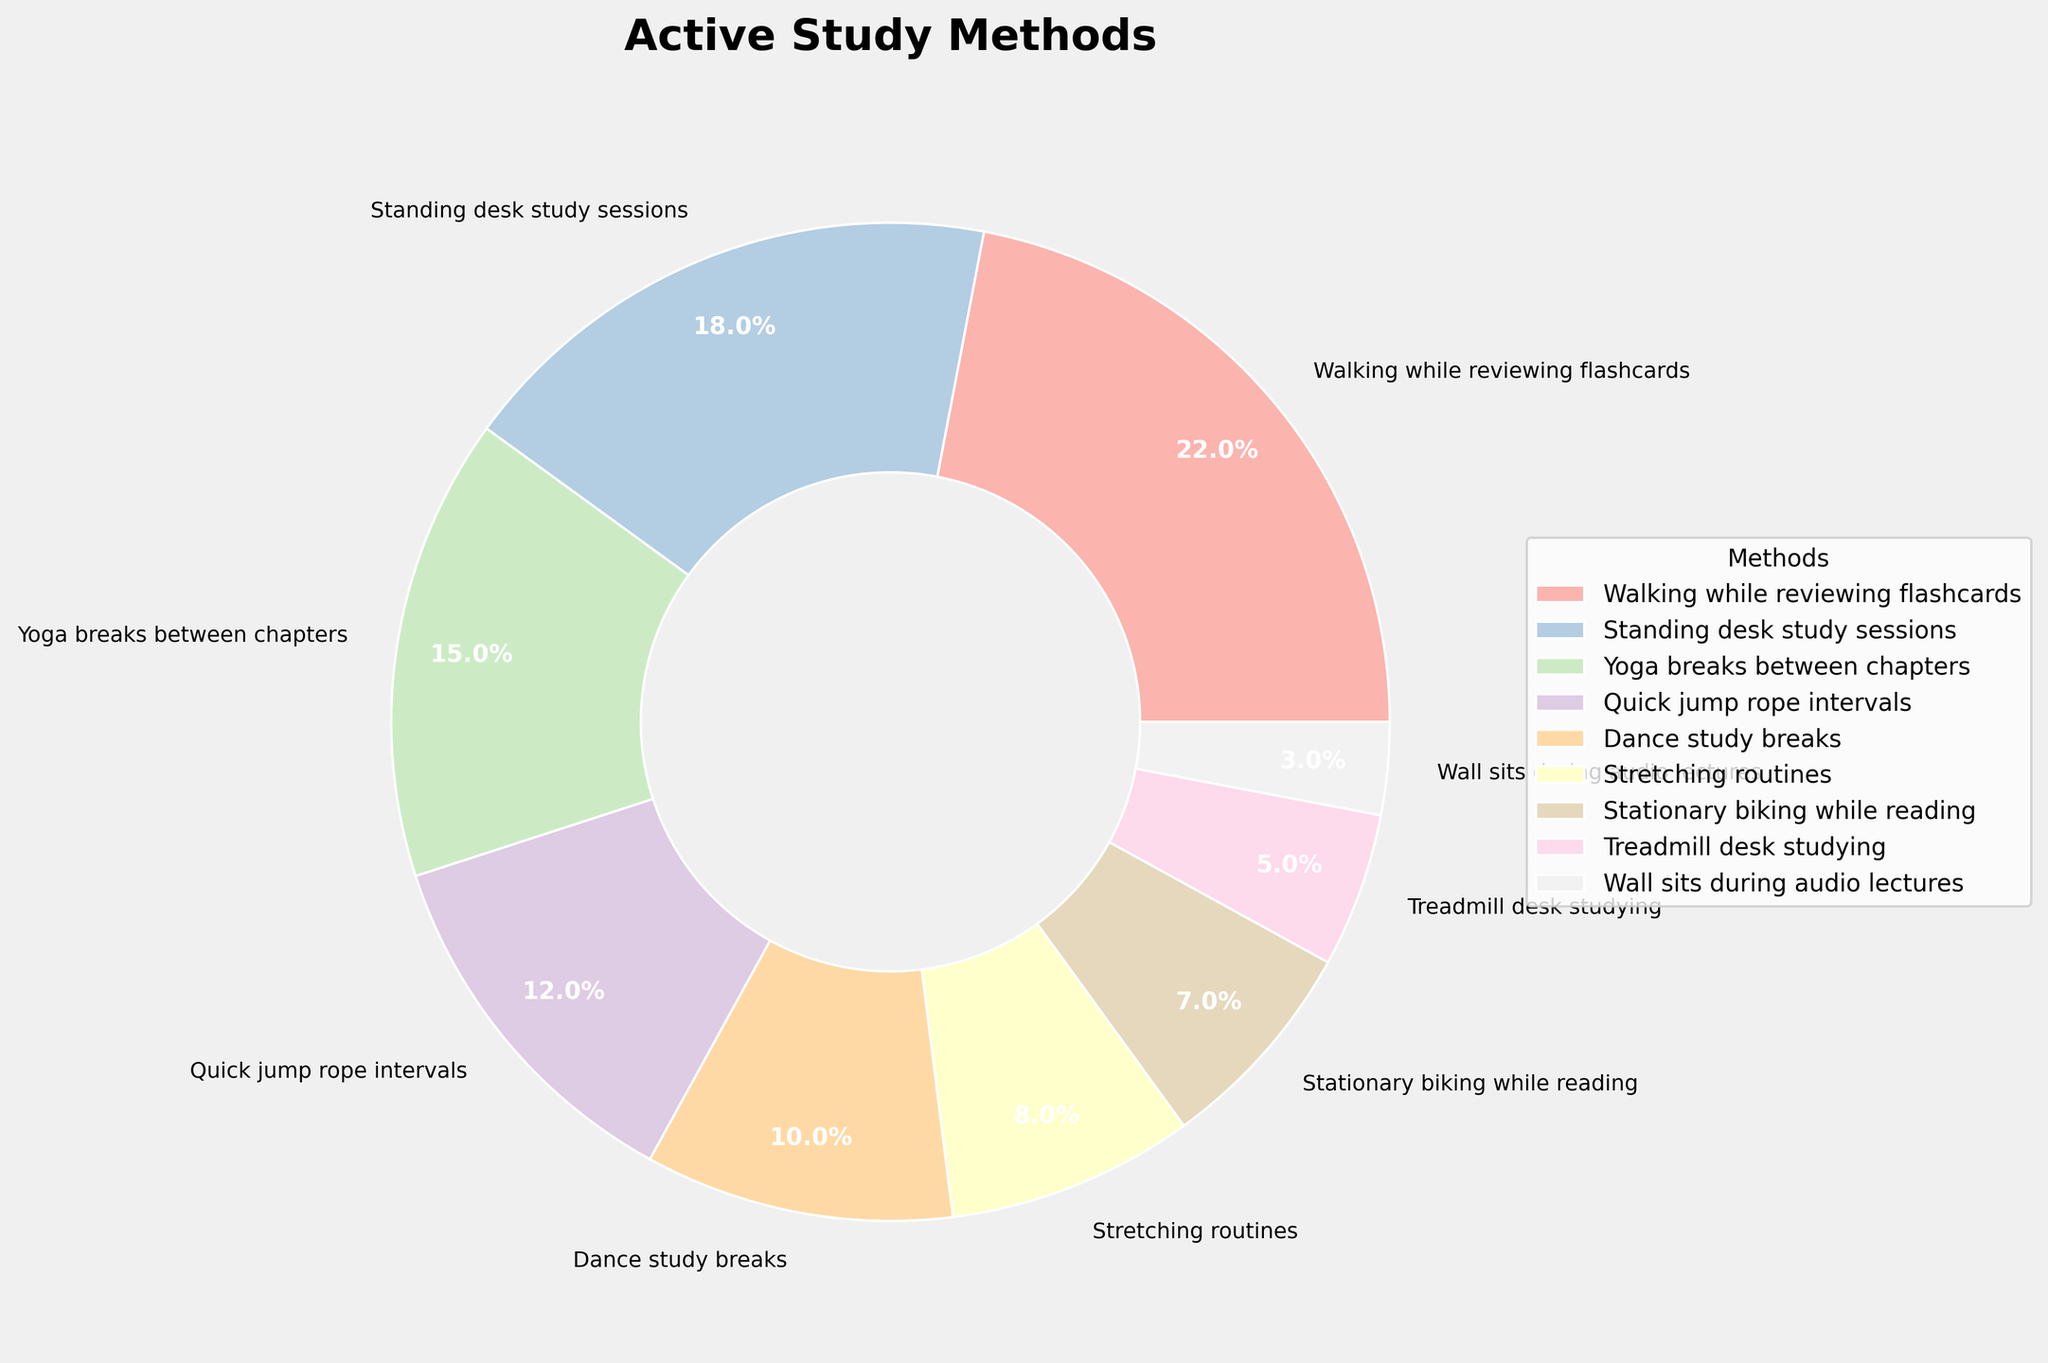What is the most common active study method among the students? Refer to the figure and identify the category with the largest percentage. "Walking while reviewing flashcards" has the highest proportion of 22%.
Answer: Walking while reviewing flashcards What is the combined percentage of students using Yoga breaks between chapters and Quick jump rope intervals? Sum the percentages of "Yoga breaks between chapters" (15%) and "Quick jump rope intervals" (12%). 15% + 12% = 27%.
Answer: 27% Which study method is less popular, Stretching routines or Dance study breaks? Compare the percentages of "Stretching routines" (8%) and "Dance study breaks" (10%). "Stretching routines" has a lower percentage.
Answer: Stretching routines How much more popular is Walking while reviewing flashcards compared to Stationary biking while reading? Subtract the percentage of "Stationary biking while reading" (7%) from "Walking while reviewing flashcards" (22%). 22% - 7% = 15%.
Answer: 15% Are there more students using Standing desk study sessions or Treadmill desk studying? Compare the percentages of "Standing desk study sessions" (18%) and "Treadmill desk studying" (5%). "Standing desk study sessions" has a higher percentage.
Answer: Standing desk study sessions If you combine the percentages of the three least popular methods, does it exceed the percentage of the most popular method? Identify the three least popular methods: "Wall sits during audio lectures" (3%), "Treadmill desk studying" (5%), and "Stationary biking while reading" (7%). Sum their percentages 3% + 5% + 7% = 15%. Compare it with the percentage of the most popular method, "Walking while reviewing flashcards" (22%). 15% < 22%.
Answer: No What percentage of students use any forms of exercise equipment (Stationary biking and Treadmill desk)? Sum the percentages of "Stationary biking while reading" (7%) and "Treadmill desk studying" (5%). 7% + 5% = 12%.
Answer: 12% Which is less common, Yoga breaks between chapters or Walking while reviewing flashcards? Compare the percentages of "Yoga breaks between chapters" (15%) and "Walking while reviewing flashcards" (22%). "Yoga breaks between chapters" is less common.
Answer: Yoga breaks between chapters 